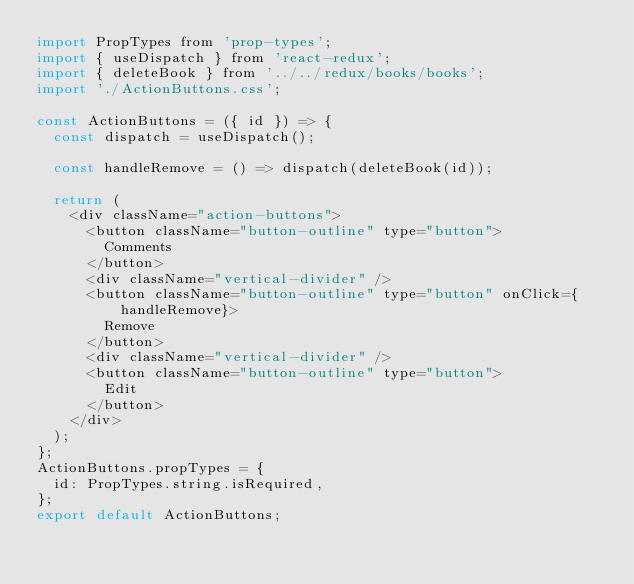<code> <loc_0><loc_0><loc_500><loc_500><_JavaScript_>import PropTypes from 'prop-types';
import { useDispatch } from 'react-redux';
import { deleteBook } from '../../redux/books/books';
import './ActionButtons.css';

const ActionButtons = ({ id }) => {
  const dispatch = useDispatch();

  const handleRemove = () => dispatch(deleteBook(id));

  return (
    <div className="action-buttons">
      <button className="button-outline" type="button">
        Comments
      </button>
      <div className="vertical-divider" />
      <button className="button-outline" type="button" onClick={handleRemove}>
        Remove
      </button>
      <div className="vertical-divider" />
      <button className="button-outline" type="button">
        Edit
      </button>
    </div>
  );
};
ActionButtons.propTypes = {
  id: PropTypes.string.isRequired,
};
export default ActionButtons;
</code> 